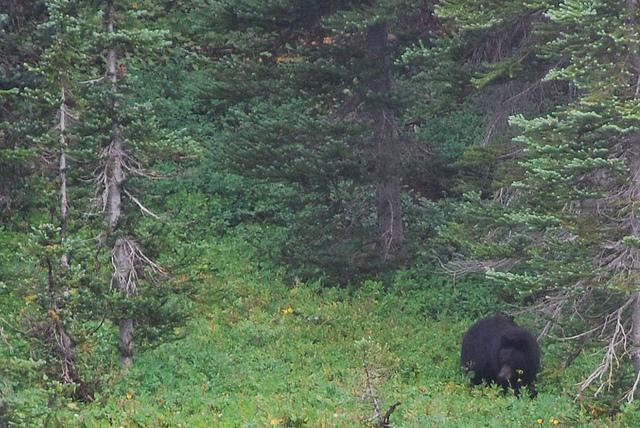Would it be safe to approach this bear?
Answer briefly. No. How many bears are in this area?
Answer briefly. 1. Are all of the trees vertical?
Be succinct. Yes. Are the bears in the wild?
Give a very brief answer. Yes. Where do most bears live?
Quick response, please. Woods. Is there a bear?
Write a very short answer. Yes. 